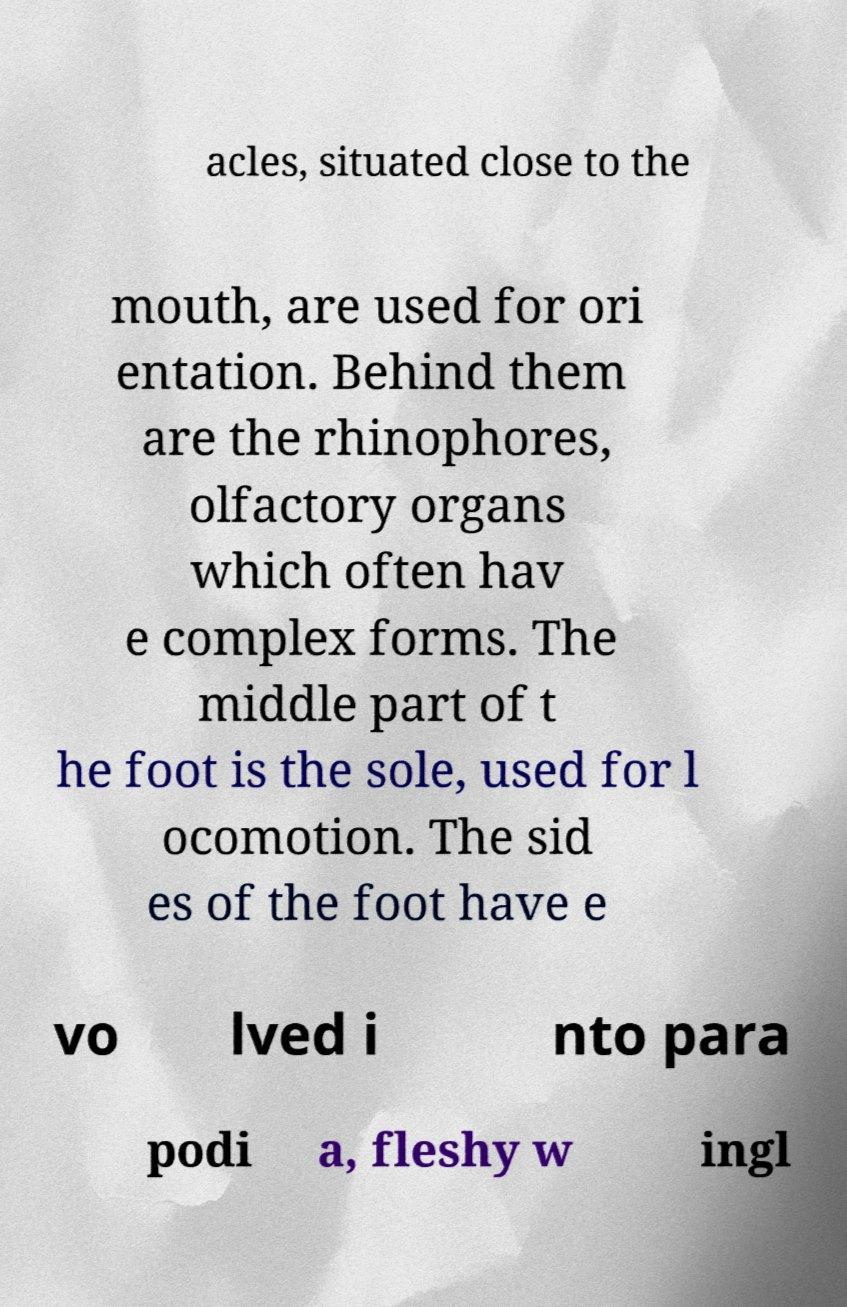I need the written content from this picture converted into text. Can you do that? acles, situated close to the mouth, are used for ori entation. Behind them are the rhinophores, olfactory organs which often hav e complex forms. The middle part of t he foot is the sole, used for l ocomotion. The sid es of the foot have e vo lved i nto para podi a, fleshy w ingl 